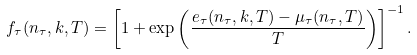Convert formula to latex. <formula><loc_0><loc_0><loc_500><loc_500>f _ { \tau } ( n _ { \tau } , k , T ) = \left [ 1 + \exp \left ( \frac { e _ { \tau } ( n _ { \tau } , k , T ) - \mu _ { \tau } ( n _ { \tau } , T ) } { T } \right ) \right ] ^ { - 1 } .</formula> 